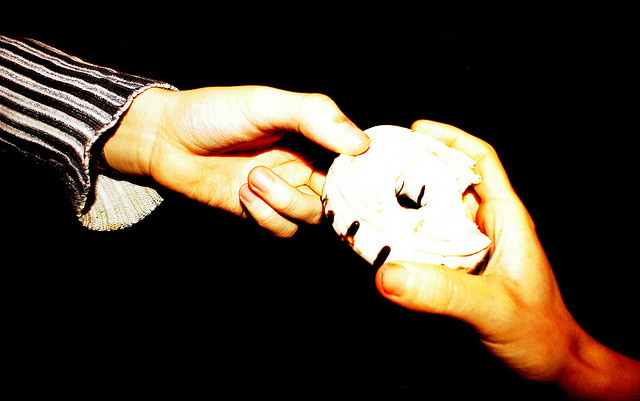<image>Does the man know the person he is handing the item to? It is unknown if the man knows the person he is handing the item to. Does the man know the person he is handing the item to? I don't know if the man knows the person he is handing the item to. It can be both yes and no. 